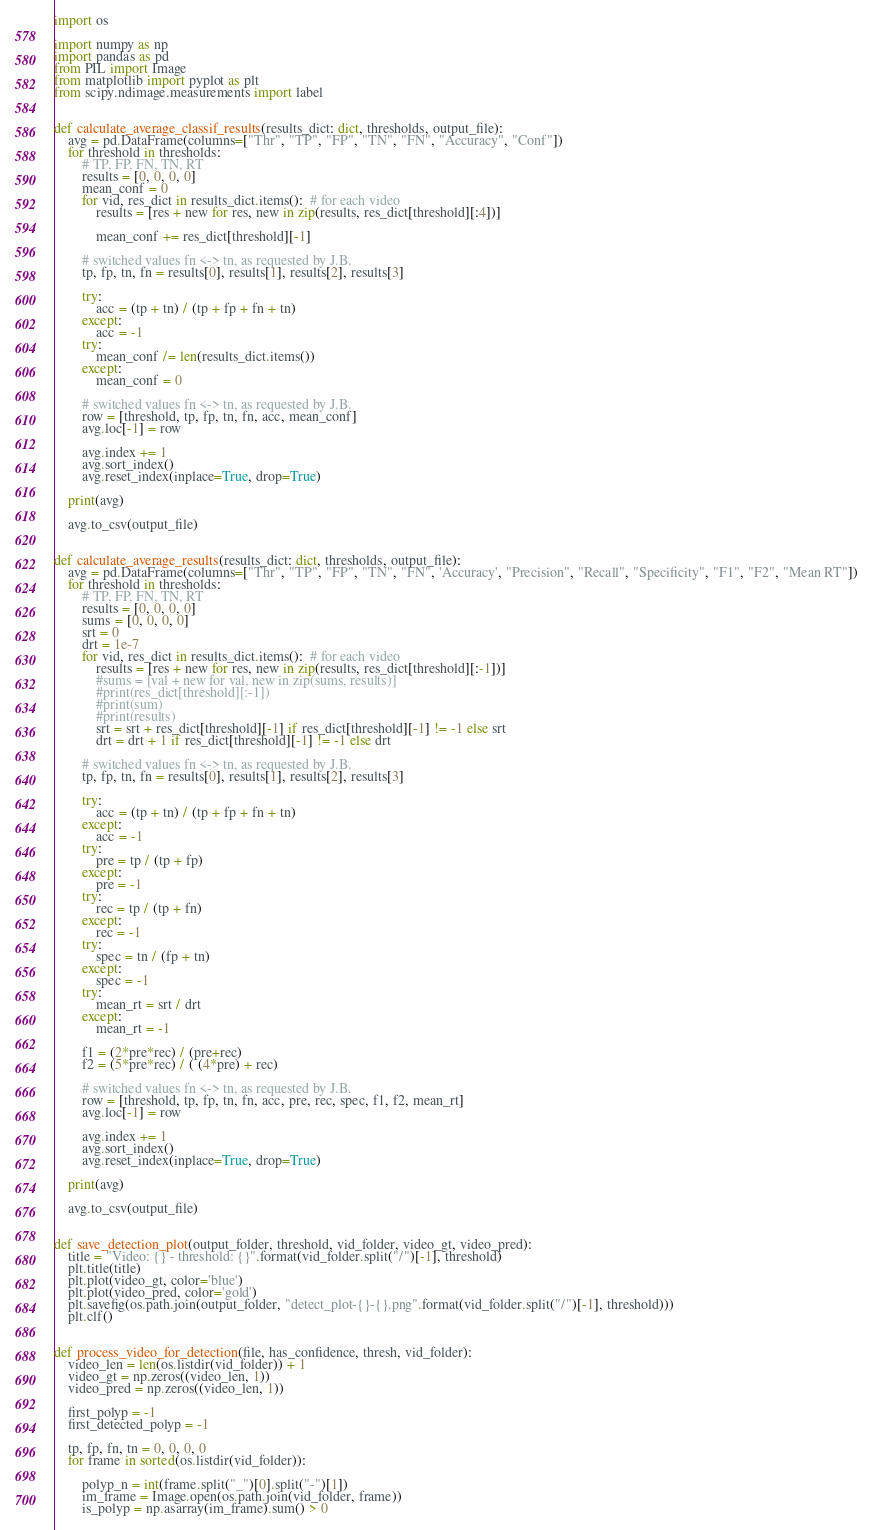<code> <loc_0><loc_0><loc_500><loc_500><_Python_>import os

import numpy as np
import pandas as pd
from PIL import Image
from matplotlib import pyplot as plt
from scipy.ndimage.measurements import label


def calculate_average_classif_results(results_dict: dict, thresholds, output_file):
    avg = pd.DataFrame(columns=["Thr", "TP", "FP", "TN", "FN", "Accuracy", "Conf"])
    for threshold in thresholds:
        # TP, FP, FN, TN, RT
        results = [0, 0, 0, 0]
        mean_conf = 0
        for vid, res_dict in results_dict.items():  # for each video
            results = [res + new for res, new in zip(results, res_dict[threshold][:4])]

            mean_conf += res_dict[threshold][-1]

        # switched values fn <-> tn, as requested by J.B.
        tp, fp, tn, fn = results[0], results[1], results[2], results[3]

        try:
            acc = (tp + tn) / (tp + fp + fn + tn)
        except:
            acc = -1
        try:
            mean_conf /= len(results_dict.items())
        except:
            mean_conf = 0

        # switched values fn <-> tn, as requested by J.B.
        row = [threshold, tp, fp, tn, fn, acc, mean_conf]
        avg.loc[-1] = row

        avg.index += 1
        avg.sort_index()
        avg.reset_index(inplace=True, drop=True)

    print(avg)

    avg.to_csv(output_file)


def calculate_average_results(results_dict: dict, thresholds, output_file):
    avg = pd.DataFrame(columns=["Thr", "TP", "FP", "TN", "FN", 'Accuracy', "Precision", "Recall", "Specificity", "F1", "F2", "Mean RT"])
    for threshold in thresholds:
        # TP, FP, FN, TN, RT
        results = [0, 0, 0, 0]
        sums = [0, 0, 0, 0]
        srt = 0
        drt = 1e-7
        for vid, res_dict in results_dict.items():  # for each video
            results = [res + new for res, new in zip(results, res_dict[threshold][:-1])]
            #sums = [val + new for val, new in zip(sums, results)]
            #print(res_dict[threshold][:-1])
            #print(sum)
            #print(results)
            srt = srt + res_dict[threshold][-1] if res_dict[threshold][-1] != -1 else srt
            drt = drt + 1 if res_dict[threshold][-1] != -1 else drt

        # switched values fn <-> tn, as requested by J.B.
        tp, fp, tn, fn = results[0], results[1], results[2], results[3]

        try:
            acc = (tp + tn) / (tp + fp + fn + tn)
        except:
            acc = -1
        try:
            pre = tp / (tp + fp)
        except:
            pre = -1
        try:
            rec = tp / (tp + fn)
        except:
            rec = -1
        try:
            spec = tn / (fp + tn)
        except:
            spec = -1
        try:
            mean_rt = srt / drt
        except:
            mean_rt = -1

        f1 = (2*pre*rec) / (pre+rec)
        f2 = (5*pre*rec) / ( (4*pre) + rec)

        # switched values fn <-> tn, as requested by J.B.
        row = [threshold, tp, fp, tn, fn, acc, pre, rec, spec, f1, f2, mean_rt]
        avg.loc[-1] = row

        avg.index += 1
        avg.sort_index()
        avg.reset_index(inplace=True, drop=True)

    print(avg)

    avg.to_csv(output_file)


def save_detection_plot(output_folder, threshold, vid_folder, video_gt, video_pred):
    title = "Video: {} - threshold: {}".format(vid_folder.split("/")[-1], threshold)
    plt.title(title)
    plt.plot(video_gt, color='blue')
    plt.plot(video_pred, color='gold')
    plt.savefig(os.path.join(output_folder, "detect_plot-{}-{}.png".format(vid_folder.split("/")[-1], threshold)))
    plt.clf()


def process_video_for_detection(file, has_confidence, thresh, vid_folder):
    video_len = len(os.listdir(vid_folder)) + 1
    video_gt = np.zeros((video_len, 1))
    video_pred = np.zeros((video_len, 1))

    first_polyp = -1
    first_detected_polyp = -1

    tp, fp, fn, tn = 0, 0, 0, 0
    for frame in sorted(os.listdir(vid_folder)):

        polyp_n = int(frame.split("_")[0].split("-")[1])
        im_frame = Image.open(os.path.join(vid_folder, frame))
        is_polyp = np.asarray(im_frame).sum() > 0</code> 